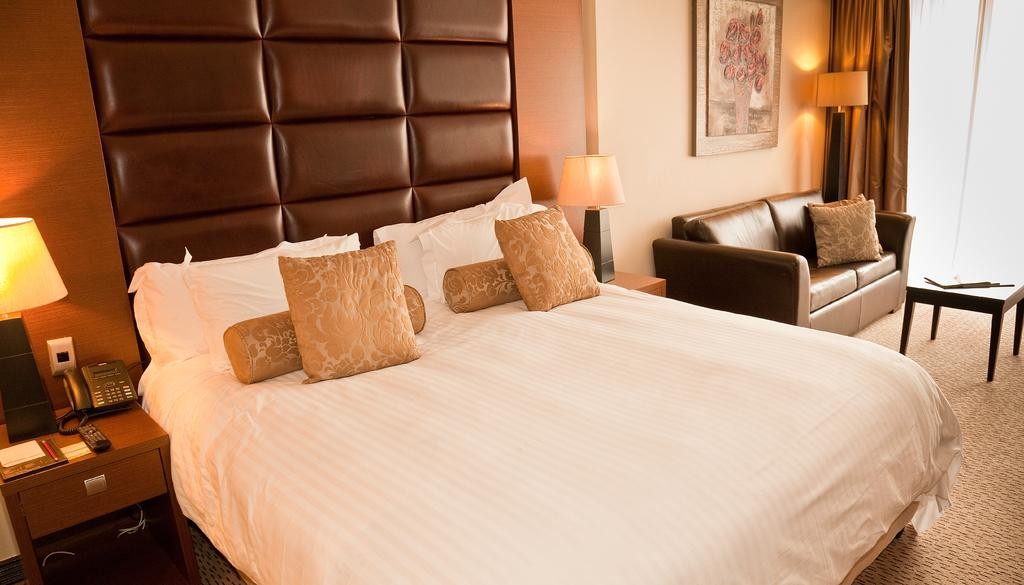What type of furniture is present in the image? There is a bed and a sofa in the image. What can be found on the bed? There are cushions on the bed. What type of lighting is present in the image? There are lamps in the image. What communication device is visible in the image? There is a telephone in the image. What type of decoration is on the wall in the image? There is a painting on the wall in the image. How many girls are playing with the tooth and ducks in the image? There are no girls, tooth, or ducks present in the image. 